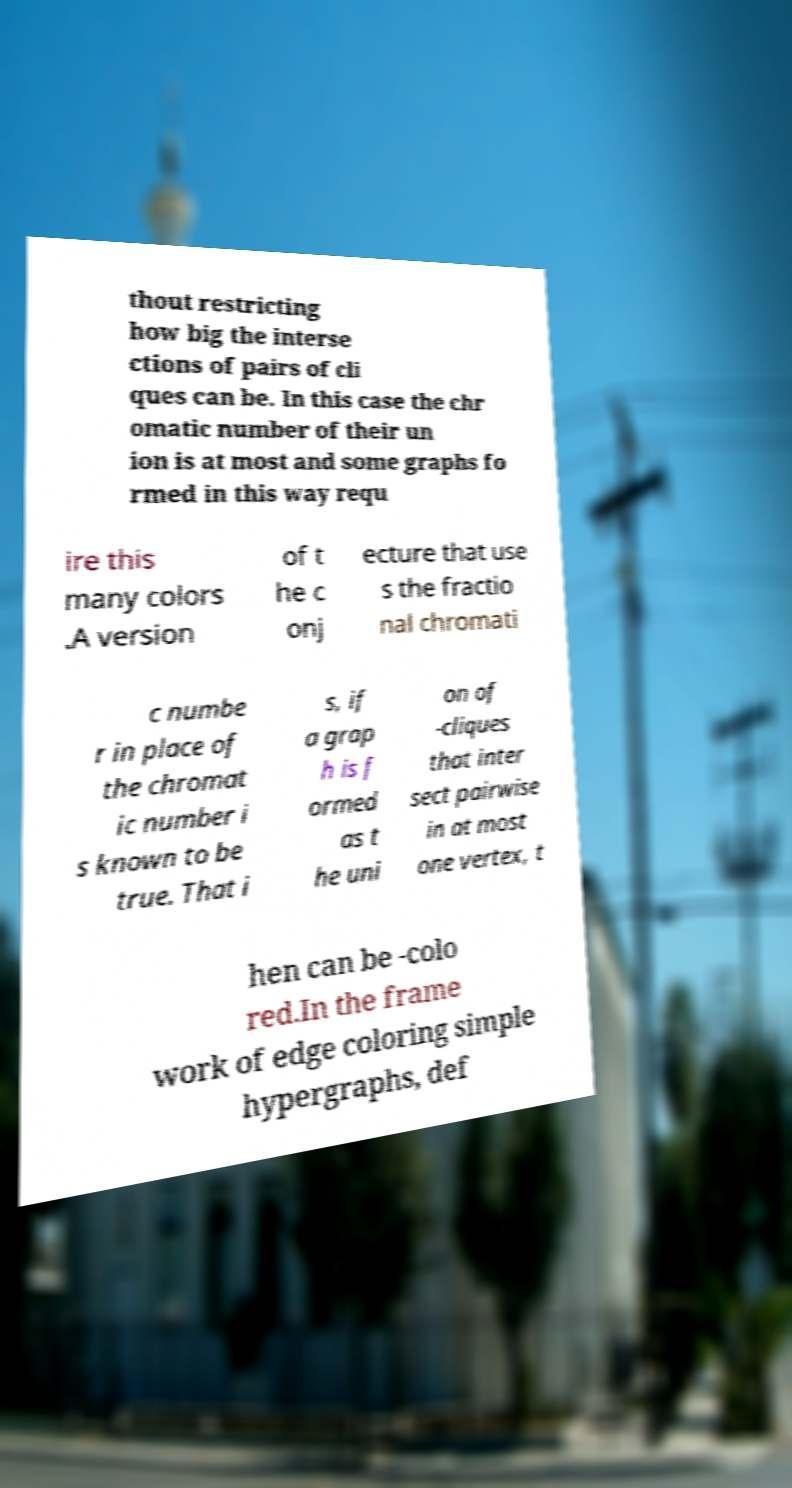Could you assist in decoding the text presented in this image and type it out clearly? thout restricting how big the interse ctions of pairs of cli ques can be. In this case the chr omatic number of their un ion is at most and some graphs fo rmed in this way requ ire this many colors .A version of t he c onj ecture that use s the fractio nal chromati c numbe r in place of the chromat ic number i s known to be true. That i s, if a grap h is f ormed as t he uni on of -cliques that inter sect pairwise in at most one vertex, t hen can be -colo red.In the frame work of edge coloring simple hypergraphs, def 